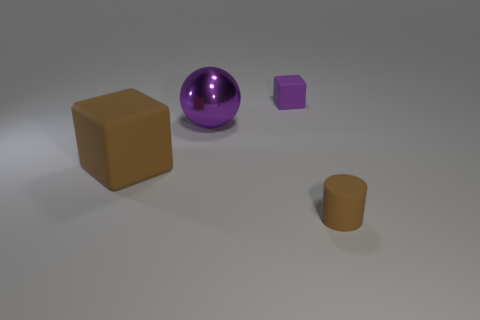There is a small thing in front of the large brown block; is its shape the same as the tiny object behind the big purple object?
Your answer should be compact. No. How many balls are small purple matte objects or brown matte things?
Your response must be concise. 0. What is the material of the brown thing that is on the left side of the purple thing to the right of the big purple object behind the brown cube?
Provide a short and direct response. Rubber. How many other things are there of the same size as the purple rubber cube?
Your response must be concise. 1. What is the size of the rubber thing that is the same color as the metallic thing?
Provide a short and direct response. Small. Are there more tiny matte objects to the left of the big purple object than blue rubber objects?
Provide a short and direct response. No. Are there any tiny matte cylinders that have the same color as the tiny matte cube?
Ensure brevity in your answer.  No. What color is the rubber cube that is the same size as the cylinder?
Offer a terse response. Purple. What number of brown things are behind the brown thing that is to the right of the purple sphere?
Your response must be concise. 1. How many objects are cubes that are behind the large brown block or big spheres?
Make the answer very short. 2. 